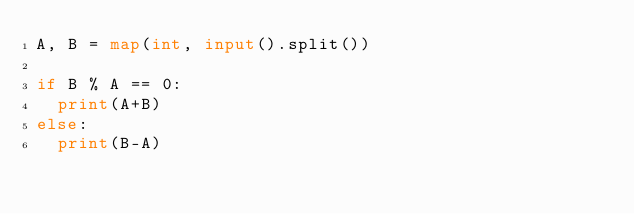<code> <loc_0><loc_0><loc_500><loc_500><_Python_>A, B = map(int, input().split())

if B % A == 0:
	print(A+B)
else:
	print(B-A)
</code> 